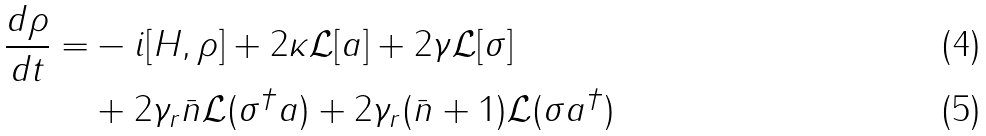<formula> <loc_0><loc_0><loc_500><loc_500>\frac { d \rho } { d t } = & - i [ H , \rho ] + 2 \kappa \mathcal { L } [ a ] + 2 \gamma \mathcal { L } [ \sigma ] \\ & + 2 \gamma _ { r } \bar { n } \mathcal { L } ( \sigma ^ { \dag } a ) + 2 \gamma _ { r } ( \bar { n } + 1 ) \mathcal { L } ( \sigma a ^ { \dag } )</formula> 